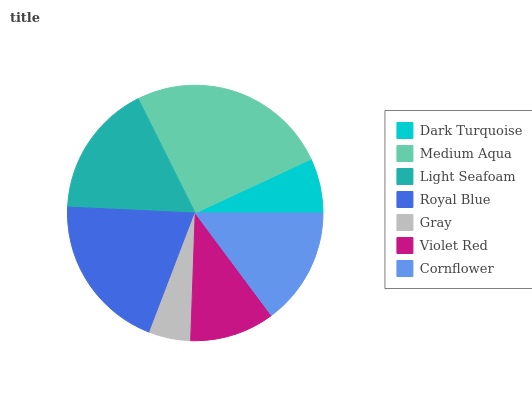Is Gray the minimum?
Answer yes or no. Yes. Is Medium Aqua the maximum?
Answer yes or no. Yes. Is Light Seafoam the minimum?
Answer yes or no. No. Is Light Seafoam the maximum?
Answer yes or no. No. Is Medium Aqua greater than Light Seafoam?
Answer yes or no. Yes. Is Light Seafoam less than Medium Aqua?
Answer yes or no. Yes. Is Light Seafoam greater than Medium Aqua?
Answer yes or no. No. Is Medium Aqua less than Light Seafoam?
Answer yes or no. No. Is Cornflower the high median?
Answer yes or no. Yes. Is Cornflower the low median?
Answer yes or no. Yes. Is Gray the high median?
Answer yes or no. No. Is Medium Aqua the low median?
Answer yes or no. No. 